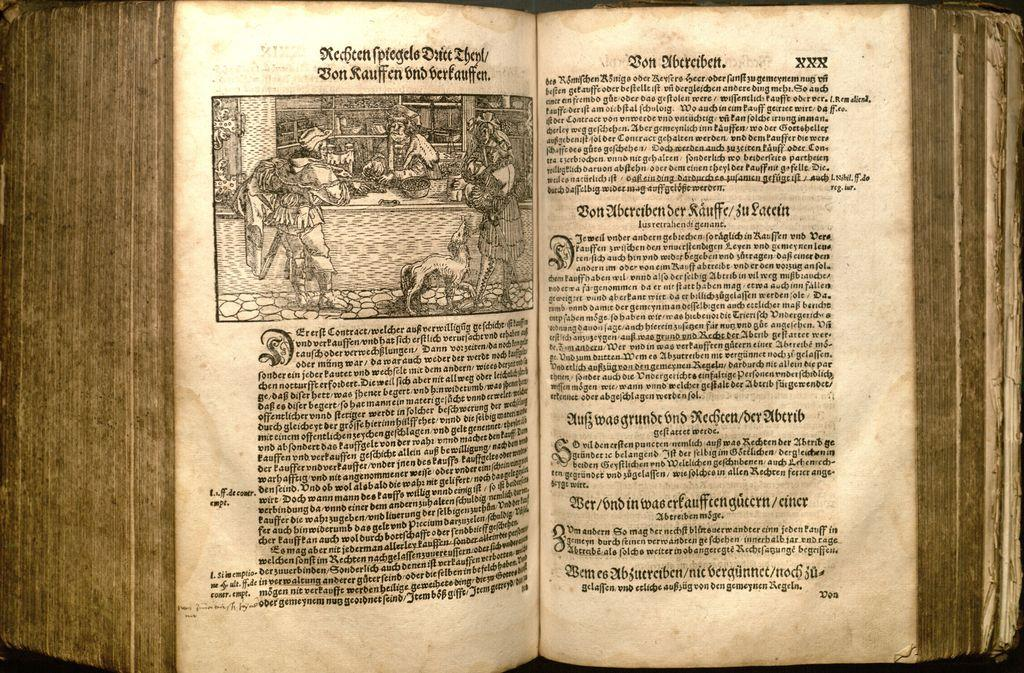<image>
Share a concise interpretation of the image provided. The old book is opened to the page XXX. 